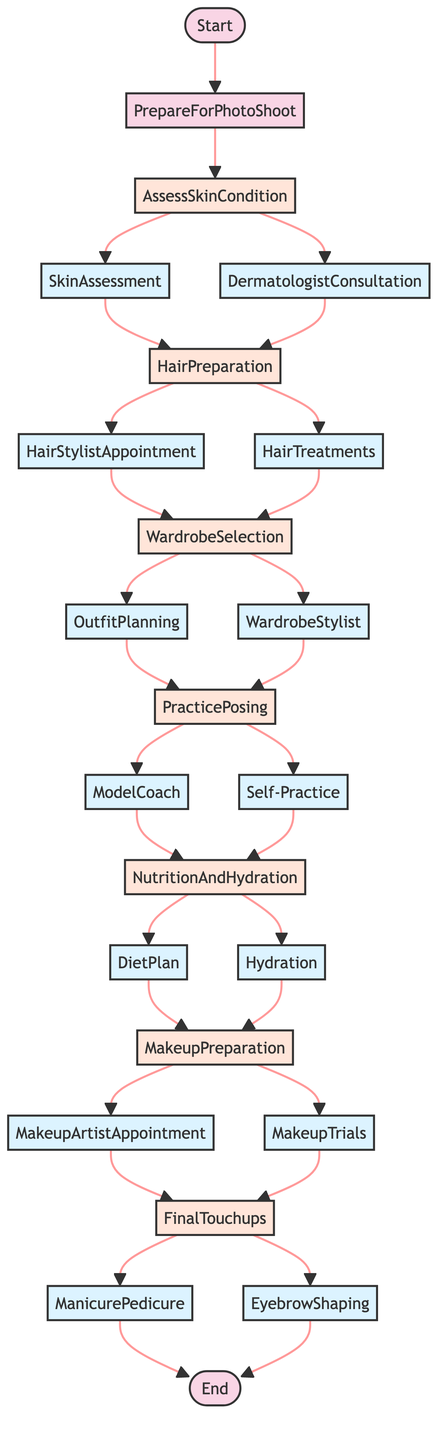what's the first step in the photo shoot preparation? The diagram shows that the first step after the "Start" node is "AssessSkinCondition." This is the initial action taken before proceeding to other steps.
Answer: AssessSkinCondition how many main steps are there in the preparation process? In the diagram, there are six main steps listed: AssessSkinCondition, HairPreparation, WardrobeSelection, PracticePosing, NutritionAndHydration, MakeupPreparation, and FinalTouchups. Counting these gives a total of six main steps.
Answer: 6 what actions are associated with HairPreparation? The "HairPreparation" step has two associated actions: "HairStylistAppointment" and "HairTreatments." These actions indicate what needs to be done during the hair preparation phase.
Answer: HairStylistAppointment, HairTreatments what step follows after NutritionAndHydration? The next step after "NutritionAndHydration" in the flowchart is "MakeupPreparation." This indicates that after focusing on diet and hydration, one should proceed to makeup.
Answer: MakeupPreparation how does one move from PracticePosing to NutritionAndHydration? The transition from "PracticePosing" to "NutritionAndHydration" occurs through actions associated with both nodes: "ModelCoach" and "Self-Practice" lead to the NutritionAndHydration step. Thus, these actions result in the next logical step in preparation.
Answer: ModelCoach, Self-Practice which step leads to the final touchups? The "MakeupPreparation" step leads to "FinalTouchups." The diagram indicates that after preparing the makeup, one needs to focus on the final enhancements.
Answer: MakeupPreparation what is needed before the makeup trials? Prior to the "MakeupTrials," one must have the "MakeupArtistAppointment." The diagram shows that scheduling this appointment is essential before trying out makeup looks.
Answer: MakeupArtistAppointment what does the FinalTouchups step consist of? The "FinalTouchups" step consists of two actions: "ManicurePedicure" and "EyebrowShaping." These actions indicate the last grooming touches needed before the photo shoot.
Answer: ManicurePedicure, EyebrowShaping how are diet and hydration related to the preparation process? Diet and hydration are crucial for maintaining energy and skin health, leading through the NutritionAndHydration step to the MakeupPreparation. The flowchart shows they feed into preparing for the makeup application.
Answer: NutritionAndHydration 